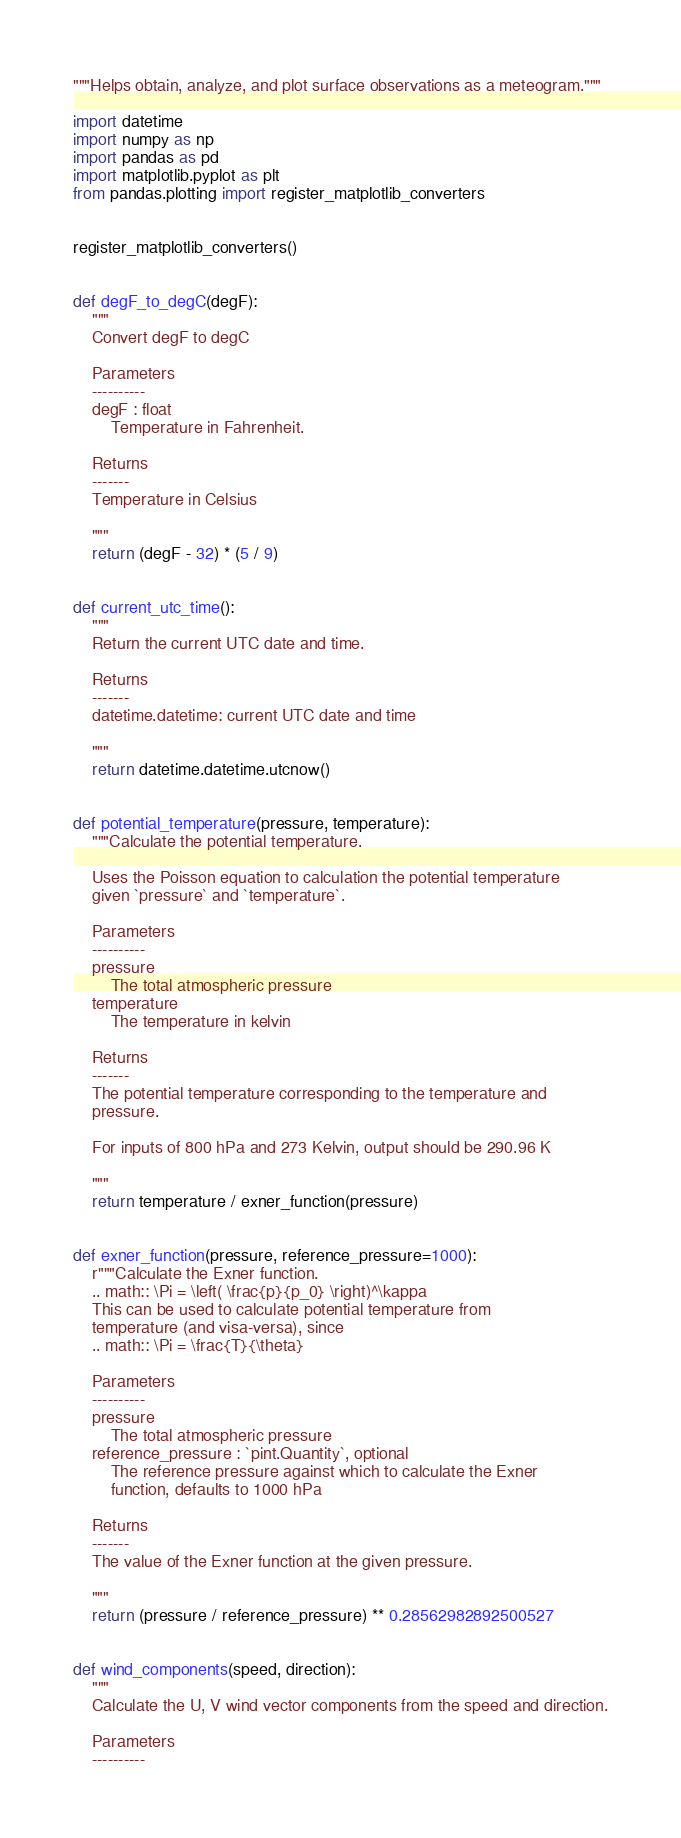<code> <loc_0><loc_0><loc_500><loc_500><_Python_>"""Helps obtain, analyze, and plot surface observations as a meteogram."""

import datetime
import numpy as np
import pandas as pd
import matplotlib.pyplot as plt
from pandas.plotting import register_matplotlib_converters


register_matplotlib_converters()


def degF_to_degC(degF):
    """
    Convert degF to degC

    Parameters
    ----------
    degF : float
        Temperature in Fahrenheit.

    Returns
    -------
    Temperature in Celsius

    """
    return (degF - 32) * (5 / 9)


def current_utc_time():
    """
    Return the current UTC date and time.

    Returns
    -------
    datetime.datetime: current UTC date and time

    """
    return datetime.datetime.utcnow()


def potential_temperature(pressure, temperature):
    """Calculate the potential temperature.

    Uses the Poisson equation to calculation the potential temperature
    given `pressure` and `temperature`.

    Parameters
    ----------
    pressure
        The total atmospheric pressure
    temperature
        The temperature in kelvin

    Returns
    -------
    The potential temperature corresponding to the temperature and
    pressure.

    For inputs of 800 hPa and 273 Kelvin, output should be 290.96 K

    """
    return temperature / exner_function(pressure)


def exner_function(pressure, reference_pressure=1000):
    r"""Calculate the Exner function.
    .. math:: \Pi = \left( \frac{p}{p_0} \right)^\kappa
    This can be used to calculate potential temperature from
    temperature (and visa-versa), since
    .. math:: \Pi = \frac{T}{\theta}

    Parameters
    ----------
    pressure
        The total atmospheric pressure
    reference_pressure : `pint.Quantity`, optional
        The reference pressure against which to calculate the Exner
        function, defaults to 1000 hPa

    Returns
    -------
    The value of the Exner function at the given pressure.

    """
    return (pressure / reference_pressure) ** 0.28562982892500527


def wind_components(speed, direction):
    """
    Calculate the U, V wind vector components from the speed and direction.

    Parameters
    ----------</code> 